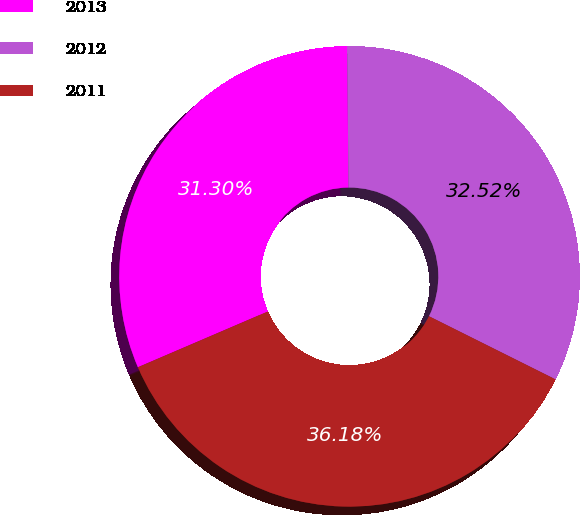Convert chart to OTSL. <chart><loc_0><loc_0><loc_500><loc_500><pie_chart><fcel>2013<fcel>2012<fcel>2011<nl><fcel>31.3%<fcel>32.52%<fcel>36.18%<nl></chart> 